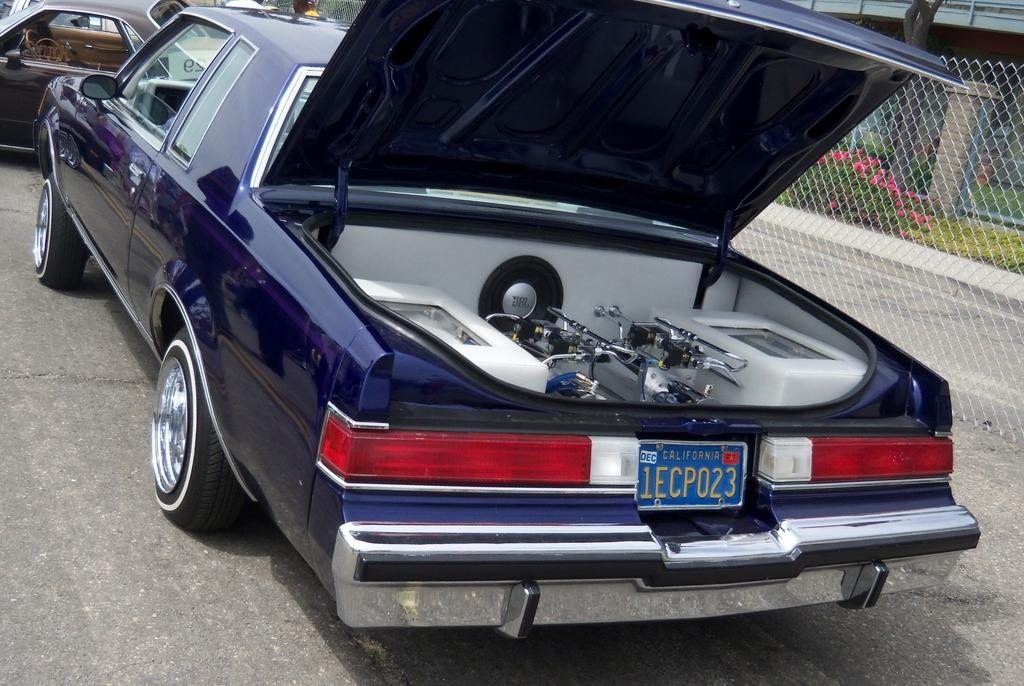<image>
Write a terse but informative summary of the picture. A car with the tag reading 1ECP023 has an open trunk. 